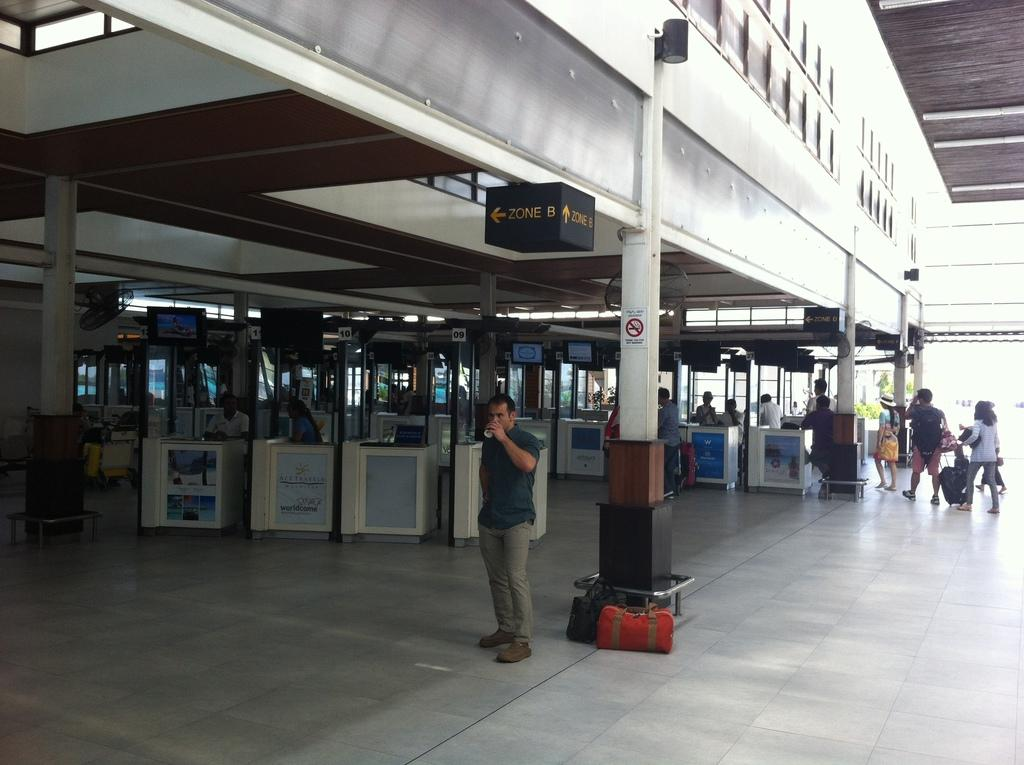How many people can be seen in the image? There are many people in the image. What type of furniture is present in the image? There are chairs and tables in the image. What electronic devices are visible in the image? There are TVs in the image. Can you describe the location depicted in the image? The location appears to be a railway station. Where is the hole in the roof of the railway station in the image? There is no hole in the roof of the railway station in the image, as the roof is not visible. What type of honey can be seen in the image? There is no honey present in the image. 